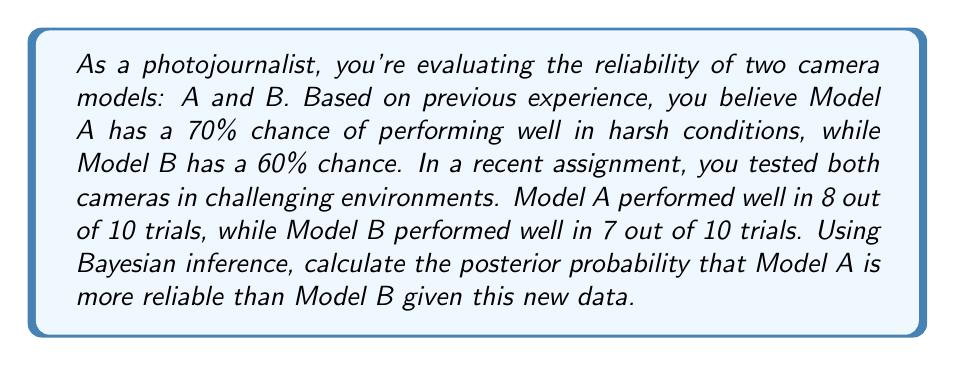Give your solution to this math problem. To solve this problem using Bayesian inference, we'll follow these steps:

1. Define the prior probabilities:
   $P(A) = 0.70$ (prior probability of Model A being reliable)
   $P(B) = 0.60$ (prior probability of Model B being reliable)

2. Calculate the likelihood of the observed data for each model:
   For Model A: $P(D_A|A) = \binom{10}{8} 0.70^8 0.30^2$
   For Model B: $P(D_B|B) = \binom{10}{7} 0.60^7 0.40^3$

3. Calculate the posterior probabilities using Bayes' theorem:
   $P(A|D_A) = \frac{P(D_A|A) \cdot P(A)}{P(D_A)}$
   $P(B|D_B) = \frac{P(D_B|B) \cdot P(B)}{P(D_B)}$

   Where $P(D_A)$ and $P(D_B)$ are the marginal likelihoods, which can be calculated using the law of total probability.

4. Calculate the probability that Model A is more reliable than Model B:
   $P(A > B | D_A, D_B) = P(A|D_A) \cdot (1 - P(B|D_B))$

Let's perform the calculations:

1. Prior probabilities are given.

2. Likelihood calculations:
   $P(D_A|A) = \binom{10}{8} 0.70^8 0.30^2 = 0.2334$
   $P(D_B|B) = \binom{10}{7} 0.60^7 0.40^3 = 0.2162$

3. Posterior probabilities:
   $P(D_A) = P(D_A|A) \cdot P(A) + P(D_A|\text{not }A) \cdot P(\text{not }A)$
   $= 0.2334 \cdot 0.70 + \binom{10}{8} 0.30^8 0.70^2 \cdot 0.30 = 0.1654$

   $P(D_B) = P(D_B|B) \cdot P(B) + P(D_B|\text{not }B) \cdot P(\text{not }B)$
   $= 0.2162 \cdot 0.60 + \binom{10}{7} 0.40^7 0.60^3 \cdot 0.40 = 0.1303$

   $P(A|D_A) = \frac{0.2334 \cdot 0.70}{0.1654} = 0.9873$
   $P(B|D_B) = \frac{0.2162 \cdot 0.60}{0.1303} = 0.9961$

4. Probability that Model A is more reliable than Model B:
   $P(A > B | D_A, D_B) = 0.9873 \cdot (1 - 0.9961) = 0.0038$
Answer: The posterior probability that Model A is more reliable than Model B given the new data is approximately 0.0038 or 0.38%. 